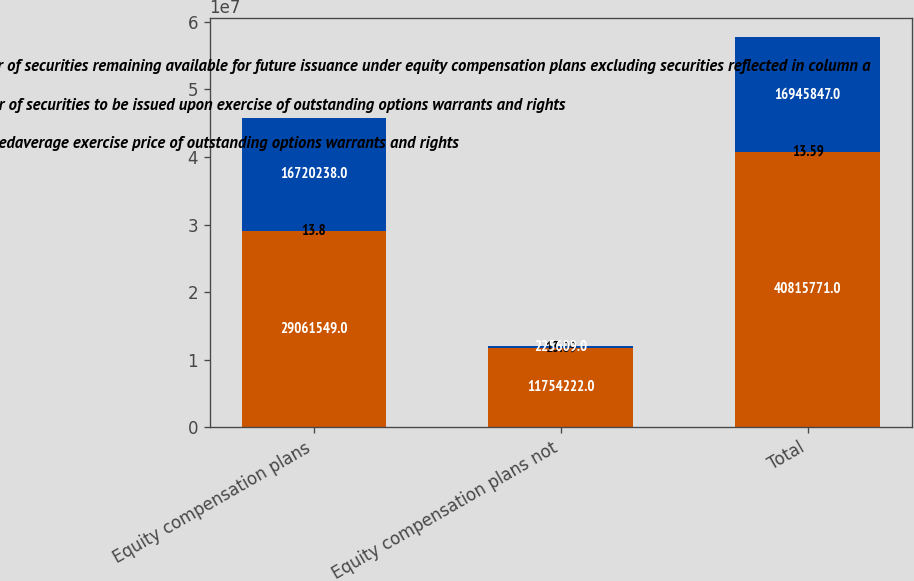<chart> <loc_0><loc_0><loc_500><loc_500><stacked_bar_chart><ecel><fcel>Equity compensation plans<fcel>Equity compensation plans not<fcel>Total<nl><fcel>c Number of securities remaining available for future issuance under equity compensation plans excluding securities reflected in column a<fcel>2.90615e+07<fcel>1.17542e+07<fcel>4.08158e+07<nl><fcel>a Number of securities to be issued upon exercise of outstanding options warrants and rights<fcel>13.8<fcel>13.09<fcel>13.59<nl><fcel>b Weightedaverage exercise price of outstanding options warrants and rights<fcel>1.67202e+07<fcel>225609<fcel>1.69458e+07<nl></chart> 